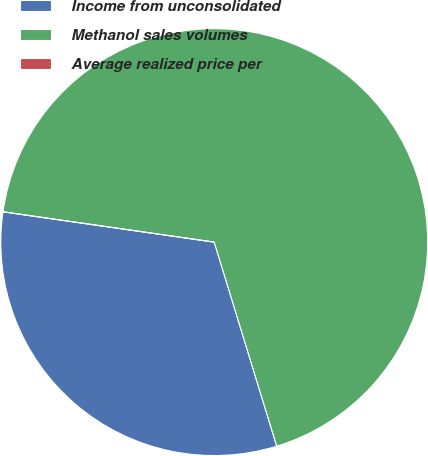<chart> <loc_0><loc_0><loc_500><loc_500><pie_chart><fcel>Income from unconsolidated<fcel>Methanol sales volumes<fcel>Average realized price per<nl><fcel>32.0%<fcel>68.0%<fcel>0.0%<nl></chart> 